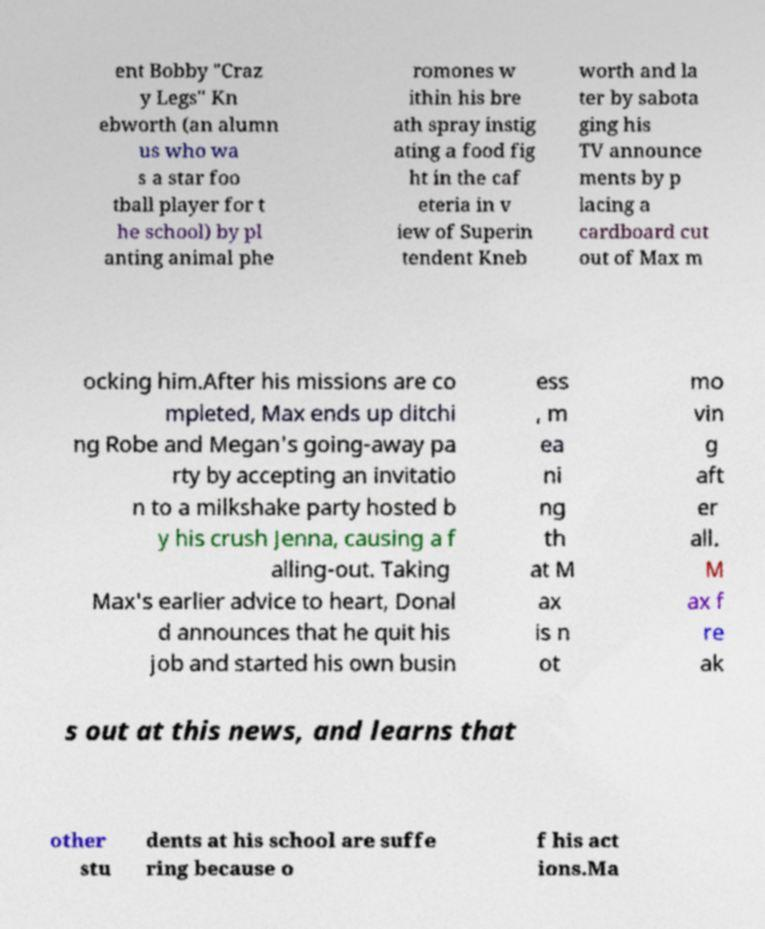Could you extract and type out the text from this image? ent Bobby "Craz y Legs" Kn ebworth (an alumn us who wa s a star foo tball player for t he school) by pl anting animal phe romones w ithin his bre ath spray instig ating a food fig ht in the caf eteria in v iew of Superin tendent Kneb worth and la ter by sabota ging his TV announce ments by p lacing a cardboard cut out of Max m ocking him.After his missions are co mpleted, Max ends up ditchi ng Robe and Megan's going-away pa rty by accepting an invitatio n to a milkshake party hosted b y his crush Jenna, causing a f alling-out. Taking Max's earlier advice to heart, Donal d announces that he quit his job and started his own busin ess , m ea ni ng th at M ax is n ot mo vin g aft er all. M ax f re ak s out at this news, and learns that other stu dents at his school are suffe ring because o f his act ions.Ma 